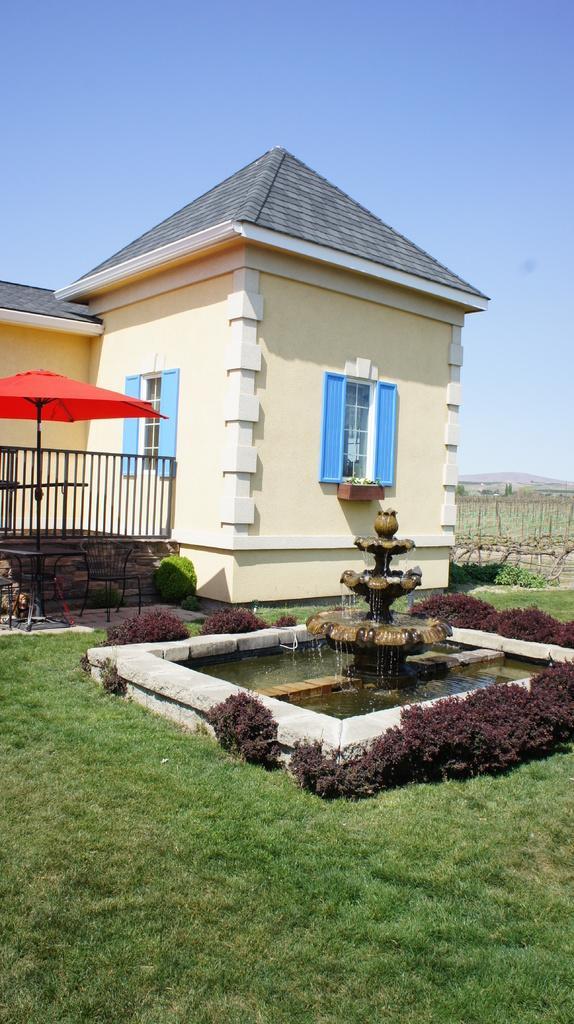In one or two sentences, can you explain what this image depicts? At the bottom of the picture, we see grass. Beside that, we see a fountain. There is a building in white color. Beside that, we see an umbrella. At the top of the picture, we see the sky. There are hills in the background. 